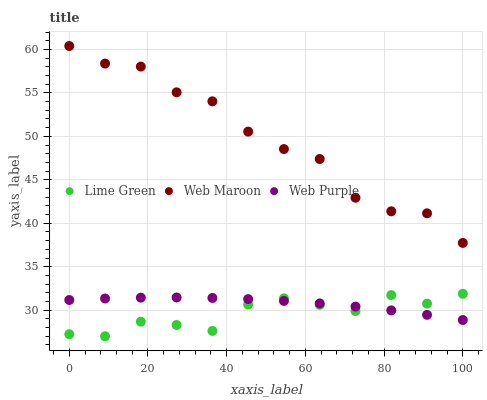Does Lime Green have the minimum area under the curve?
Answer yes or no. Yes. Does Web Maroon have the maximum area under the curve?
Answer yes or no. Yes. Does Web Purple have the minimum area under the curve?
Answer yes or no. No. Does Web Purple have the maximum area under the curve?
Answer yes or no. No. Is Web Purple the smoothest?
Answer yes or no. Yes. Is Web Maroon the roughest?
Answer yes or no. Yes. Is Lime Green the smoothest?
Answer yes or no. No. Is Lime Green the roughest?
Answer yes or no. No. Does Lime Green have the lowest value?
Answer yes or no. Yes. Does Web Purple have the lowest value?
Answer yes or no. No. Does Web Maroon have the highest value?
Answer yes or no. Yes. Does Lime Green have the highest value?
Answer yes or no. No. Is Web Purple less than Web Maroon?
Answer yes or no. Yes. Is Web Maroon greater than Web Purple?
Answer yes or no. Yes. Does Lime Green intersect Web Purple?
Answer yes or no. Yes. Is Lime Green less than Web Purple?
Answer yes or no. No. Is Lime Green greater than Web Purple?
Answer yes or no. No. Does Web Purple intersect Web Maroon?
Answer yes or no. No. 